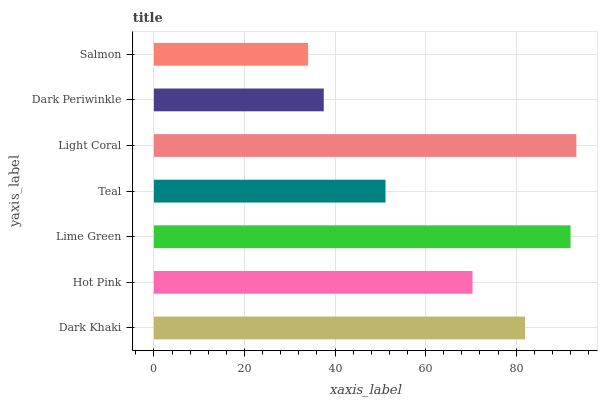Is Salmon the minimum?
Answer yes or no. Yes. Is Light Coral the maximum?
Answer yes or no. Yes. Is Hot Pink the minimum?
Answer yes or no. No. Is Hot Pink the maximum?
Answer yes or no. No. Is Dark Khaki greater than Hot Pink?
Answer yes or no. Yes. Is Hot Pink less than Dark Khaki?
Answer yes or no. Yes. Is Hot Pink greater than Dark Khaki?
Answer yes or no. No. Is Dark Khaki less than Hot Pink?
Answer yes or no. No. Is Hot Pink the high median?
Answer yes or no. Yes. Is Hot Pink the low median?
Answer yes or no. Yes. Is Light Coral the high median?
Answer yes or no. No. Is Dark Khaki the low median?
Answer yes or no. No. 